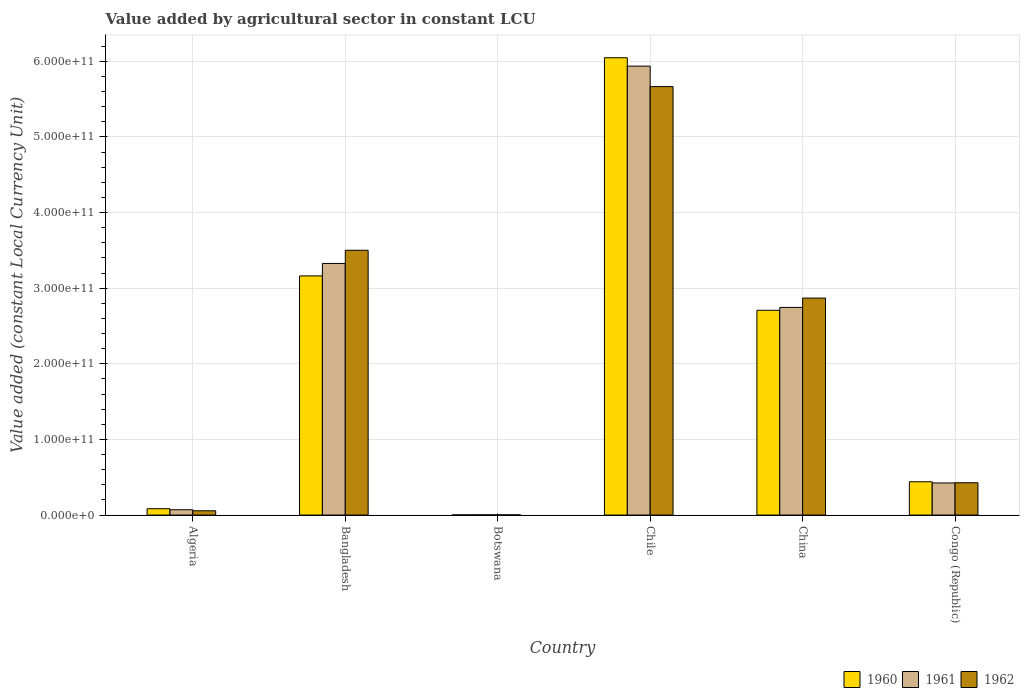How many different coloured bars are there?
Provide a short and direct response. 3. How many groups of bars are there?
Your answer should be compact. 6. How many bars are there on the 3rd tick from the right?
Keep it short and to the point. 3. In how many cases, is the number of bars for a given country not equal to the number of legend labels?
Offer a very short reply. 0. What is the value added by agricultural sector in 1961 in Chile?
Your answer should be compact. 5.94e+11. Across all countries, what is the maximum value added by agricultural sector in 1960?
Your answer should be very brief. 6.05e+11. Across all countries, what is the minimum value added by agricultural sector in 1960?
Your answer should be compact. 2.79e+08. In which country was the value added by agricultural sector in 1962 minimum?
Your answer should be very brief. Botswana. What is the total value added by agricultural sector in 1961 in the graph?
Keep it short and to the point. 1.25e+12. What is the difference between the value added by agricultural sector in 1960 in Bangladesh and that in Congo (Republic)?
Give a very brief answer. 2.72e+11. What is the difference between the value added by agricultural sector in 1962 in China and the value added by agricultural sector in 1961 in Congo (Republic)?
Keep it short and to the point. 2.44e+11. What is the average value added by agricultural sector in 1960 per country?
Offer a terse response. 2.07e+11. What is the difference between the value added by agricultural sector of/in 1961 and value added by agricultural sector of/in 1960 in Algeria?
Your answer should be very brief. -1.35e+09. What is the ratio of the value added by agricultural sector in 1961 in Bangladesh to that in Chile?
Provide a succinct answer. 0.56. What is the difference between the highest and the second highest value added by agricultural sector in 1960?
Give a very brief answer. -2.88e+11. What is the difference between the highest and the lowest value added by agricultural sector in 1961?
Keep it short and to the point. 5.93e+11. Is the sum of the value added by agricultural sector in 1962 in Algeria and Botswana greater than the maximum value added by agricultural sector in 1961 across all countries?
Your answer should be compact. No. What does the 2nd bar from the left in Chile represents?
Give a very brief answer. 1961. Is it the case that in every country, the sum of the value added by agricultural sector in 1961 and value added by agricultural sector in 1962 is greater than the value added by agricultural sector in 1960?
Your answer should be very brief. Yes. How many bars are there?
Your response must be concise. 18. How many countries are there in the graph?
Provide a short and direct response. 6. What is the difference between two consecutive major ticks on the Y-axis?
Offer a very short reply. 1.00e+11. Are the values on the major ticks of Y-axis written in scientific E-notation?
Give a very brief answer. Yes. Does the graph contain any zero values?
Your answer should be compact. No. Does the graph contain grids?
Provide a succinct answer. Yes. How are the legend labels stacked?
Keep it short and to the point. Horizontal. What is the title of the graph?
Give a very brief answer. Value added by agricultural sector in constant LCU. Does "1984" appear as one of the legend labels in the graph?
Your response must be concise. No. What is the label or title of the X-axis?
Your answer should be compact. Country. What is the label or title of the Y-axis?
Offer a terse response. Value added (constant Local Currency Unit). What is the Value added (constant Local Currency Unit) of 1960 in Algeria?
Your answer should be compact. 8.40e+09. What is the Value added (constant Local Currency Unit) in 1961 in Algeria?
Give a very brief answer. 7.05e+09. What is the Value added (constant Local Currency Unit) of 1962 in Algeria?
Keep it short and to the point. 5.66e+09. What is the Value added (constant Local Currency Unit) in 1960 in Bangladesh?
Offer a terse response. 3.16e+11. What is the Value added (constant Local Currency Unit) of 1961 in Bangladesh?
Provide a short and direct response. 3.33e+11. What is the Value added (constant Local Currency Unit) of 1962 in Bangladesh?
Provide a short and direct response. 3.50e+11. What is the Value added (constant Local Currency Unit) of 1960 in Botswana?
Ensure brevity in your answer.  2.79e+08. What is the Value added (constant Local Currency Unit) of 1961 in Botswana?
Offer a terse response. 2.86e+08. What is the Value added (constant Local Currency Unit) of 1962 in Botswana?
Provide a short and direct response. 2.96e+08. What is the Value added (constant Local Currency Unit) of 1960 in Chile?
Provide a succinct answer. 6.05e+11. What is the Value added (constant Local Currency Unit) in 1961 in Chile?
Offer a terse response. 5.94e+11. What is the Value added (constant Local Currency Unit) of 1962 in Chile?
Your answer should be very brief. 5.67e+11. What is the Value added (constant Local Currency Unit) in 1960 in China?
Provide a short and direct response. 2.71e+11. What is the Value added (constant Local Currency Unit) in 1961 in China?
Provide a short and direct response. 2.75e+11. What is the Value added (constant Local Currency Unit) in 1962 in China?
Your answer should be very brief. 2.87e+11. What is the Value added (constant Local Currency Unit) in 1960 in Congo (Republic)?
Make the answer very short. 4.41e+1. What is the Value added (constant Local Currency Unit) of 1961 in Congo (Republic)?
Your response must be concise. 4.25e+1. What is the Value added (constant Local Currency Unit) of 1962 in Congo (Republic)?
Ensure brevity in your answer.  4.27e+1. Across all countries, what is the maximum Value added (constant Local Currency Unit) of 1960?
Offer a very short reply. 6.05e+11. Across all countries, what is the maximum Value added (constant Local Currency Unit) in 1961?
Make the answer very short. 5.94e+11. Across all countries, what is the maximum Value added (constant Local Currency Unit) of 1962?
Provide a short and direct response. 5.67e+11. Across all countries, what is the minimum Value added (constant Local Currency Unit) of 1960?
Make the answer very short. 2.79e+08. Across all countries, what is the minimum Value added (constant Local Currency Unit) of 1961?
Your answer should be very brief. 2.86e+08. Across all countries, what is the minimum Value added (constant Local Currency Unit) of 1962?
Give a very brief answer. 2.96e+08. What is the total Value added (constant Local Currency Unit) in 1960 in the graph?
Make the answer very short. 1.24e+12. What is the total Value added (constant Local Currency Unit) in 1961 in the graph?
Make the answer very short. 1.25e+12. What is the total Value added (constant Local Currency Unit) of 1962 in the graph?
Make the answer very short. 1.25e+12. What is the difference between the Value added (constant Local Currency Unit) of 1960 in Algeria and that in Bangladesh?
Offer a very short reply. -3.08e+11. What is the difference between the Value added (constant Local Currency Unit) of 1961 in Algeria and that in Bangladesh?
Offer a very short reply. -3.26e+11. What is the difference between the Value added (constant Local Currency Unit) of 1962 in Algeria and that in Bangladesh?
Ensure brevity in your answer.  -3.44e+11. What is the difference between the Value added (constant Local Currency Unit) of 1960 in Algeria and that in Botswana?
Ensure brevity in your answer.  8.12e+09. What is the difference between the Value added (constant Local Currency Unit) of 1961 in Algeria and that in Botswana?
Give a very brief answer. 6.77e+09. What is the difference between the Value added (constant Local Currency Unit) in 1962 in Algeria and that in Botswana?
Offer a terse response. 5.36e+09. What is the difference between the Value added (constant Local Currency Unit) of 1960 in Algeria and that in Chile?
Provide a short and direct response. -5.96e+11. What is the difference between the Value added (constant Local Currency Unit) of 1961 in Algeria and that in Chile?
Provide a succinct answer. -5.87e+11. What is the difference between the Value added (constant Local Currency Unit) of 1962 in Algeria and that in Chile?
Keep it short and to the point. -5.61e+11. What is the difference between the Value added (constant Local Currency Unit) in 1960 in Algeria and that in China?
Keep it short and to the point. -2.62e+11. What is the difference between the Value added (constant Local Currency Unit) of 1961 in Algeria and that in China?
Ensure brevity in your answer.  -2.68e+11. What is the difference between the Value added (constant Local Currency Unit) of 1962 in Algeria and that in China?
Your response must be concise. -2.81e+11. What is the difference between the Value added (constant Local Currency Unit) of 1960 in Algeria and that in Congo (Republic)?
Your response must be concise. -3.57e+1. What is the difference between the Value added (constant Local Currency Unit) of 1961 in Algeria and that in Congo (Republic)?
Offer a very short reply. -3.54e+1. What is the difference between the Value added (constant Local Currency Unit) of 1962 in Algeria and that in Congo (Republic)?
Your response must be concise. -3.71e+1. What is the difference between the Value added (constant Local Currency Unit) in 1960 in Bangladesh and that in Botswana?
Your response must be concise. 3.16e+11. What is the difference between the Value added (constant Local Currency Unit) of 1961 in Bangladesh and that in Botswana?
Keep it short and to the point. 3.32e+11. What is the difference between the Value added (constant Local Currency Unit) in 1962 in Bangladesh and that in Botswana?
Offer a terse response. 3.50e+11. What is the difference between the Value added (constant Local Currency Unit) of 1960 in Bangladesh and that in Chile?
Make the answer very short. -2.88e+11. What is the difference between the Value added (constant Local Currency Unit) in 1961 in Bangladesh and that in Chile?
Ensure brevity in your answer.  -2.61e+11. What is the difference between the Value added (constant Local Currency Unit) of 1962 in Bangladesh and that in Chile?
Offer a terse response. -2.16e+11. What is the difference between the Value added (constant Local Currency Unit) in 1960 in Bangladesh and that in China?
Ensure brevity in your answer.  4.54e+1. What is the difference between the Value added (constant Local Currency Unit) of 1961 in Bangladesh and that in China?
Give a very brief answer. 5.81e+1. What is the difference between the Value added (constant Local Currency Unit) of 1962 in Bangladesh and that in China?
Make the answer very short. 6.32e+1. What is the difference between the Value added (constant Local Currency Unit) in 1960 in Bangladesh and that in Congo (Republic)?
Your answer should be very brief. 2.72e+11. What is the difference between the Value added (constant Local Currency Unit) in 1961 in Bangladesh and that in Congo (Republic)?
Keep it short and to the point. 2.90e+11. What is the difference between the Value added (constant Local Currency Unit) of 1962 in Bangladesh and that in Congo (Republic)?
Your answer should be very brief. 3.07e+11. What is the difference between the Value added (constant Local Currency Unit) in 1960 in Botswana and that in Chile?
Offer a terse response. -6.04e+11. What is the difference between the Value added (constant Local Currency Unit) in 1961 in Botswana and that in Chile?
Make the answer very short. -5.93e+11. What is the difference between the Value added (constant Local Currency Unit) in 1962 in Botswana and that in Chile?
Provide a succinct answer. -5.66e+11. What is the difference between the Value added (constant Local Currency Unit) of 1960 in Botswana and that in China?
Make the answer very short. -2.70e+11. What is the difference between the Value added (constant Local Currency Unit) in 1961 in Botswana and that in China?
Provide a succinct answer. -2.74e+11. What is the difference between the Value added (constant Local Currency Unit) in 1962 in Botswana and that in China?
Provide a succinct answer. -2.87e+11. What is the difference between the Value added (constant Local Currency Unit) in 1960 in Botswana and that in Congo (Republic)?
Make the answer very short. -4.38e+1. What is the difference between the Value added (constant Local Currency Unit) in 1961 in Botswana and that in Congo (Republic)?
Make the answer very short. -4.22e+1. What is the difference between the Value added (constant Local Currency Unit) of 1962 in Botswana and that in Congo (Republic)?
Your answer should be compact. -4.24e+1. What is the difference between the Value added (constant Local Currency Unit) of 1960 in Chile and that in China?
Your answer should be very brief. 3.34e+11. What is the difference between the Value added (constant Local Currency Unit) in 1961 in Chile and that in China?
Make the answer very short. 3.19e+11. What is the difference between the Value added (constant Local Currency Unit) of 1962 in Chile and that in China?
Make the answer very short. 2.80e+11. What is the difference between the Value added (constant Local Currency Unit) in 1960 in Chile and that in Congo (Republic)?
Provide a succinct answer. 5.61e+11. What is the difference between the Value added (constant Local Currency Unit) in 1961 in Chile and that in Congo (Republic)?
Provide a succinct answer. 5.51e+11. What is the difference between the Value added (constant Local Currency Unit) in 1962 in Chile and that in Congo (Republic)?
Offer a terse response. 5.24e+11. What is the difference between the Value added (constant Local Currency Unit) of 1960 in China and that in Congo (Republic)?
Make the answer very short. 2.27e+11. What is the difference between the Value added (constant Local Currency Unit) in 1961 in China and that in Congo (Republic)?
Ensure brevity in your answer.  2.32e+11. What is the difference between the Value added (constant Local Currency Unit) of 1962 in China and that in Congo (Republic)?
Ensure brevity in your answer.  2.44e+11. What is the difference between the Value added (constant Local Currency Unit) of 1960 in Algeria and the Value added (constant Local Currency Unit) of 1961 in Bangladesh?
Your response must be concise. -3.24e+11. What is the difference between the Value added (constant Local Currency Unit) in 1960 in Algeria and the Value added (constant Local Currency Unit) in 1962 in Bangladesh?
Make the answer very short. -3.42e+11. What is the difference between the Value added (constant Local Currency Unit) in 1961 in Algeria and the Value added (constant Local Currency Unit) in 1962 in Bangladesh?
Your answer should be very brief. -3.43e+11. What is the difference between the Value added (constant Local Currency Unit) of 1960 in Algeria and the Value added (constant Local Currency Unit) of 1961 in Botswana?
Ensure brevity in your answer.  8.11e+09. What is the difference between the Value added (constant Local Currency Unit) in 1960 in Algeria and the Value added (constant Local Currency Unit) in 1962 in Botswana?
Your answer should be compact. 8.10e+09. What is the difference between the Value added (constant Local Currency Unit) in 1961 in Algeria and the Value added (constant Local Currency Unit) in 1962 in Botswana?
Your answer should be compact. 6.76e+09. What is the difference between the Value added (constant Local Currency Unit) of 1960 in Algeria and the Value added (constant Local Currency Unit) of 1961 in Chile?
Provide a succinct answer. -5.85e+11. What is the difference between the Value added (constant Local Currency Unit) of 1960 in Algeria and the Value added (constant Local Currency Unit) of 1962 in Chile?
Your answer should be very brief. -5.58e+11. What is the difference between the Value added (constant Local Currency Unit) in 1961 in Algeria and the Value added (constant Local Currency Unit) in 1962 in Chile?
Give a very brief answer. -5.59e+11. What is the difference between the Value added (constant Local Currency Unit) of 1960 in Algeria and the Value added (constant Local Currency Unit) of 1961 in China?
Provide a succinct answer. -2.66e+11. What is the difference between the Value added (constant Local Currency Unit) of 1960 in Algeria and the Value added (constant Local Currency Unit) of 1962 in China?
Give a very brief answer. -2.79e+11. What is the difference between the Value added (constant Local Currency Unit) of 1961 in Algeria and the Value added (constant Local Currency Unit) of 1962 in China?
Your answer should be very brief. -2.80e+11. What is the difference between the Value added (constant Local Currency Unit) of 1960 in Algeria and the Value added (constant Local Currency Unit) of 1961 in Congo (Republic)?
Your response must be concise. -3.41e+1. What is the difference between the Value added (constant Local Currency Unit) of 1960 in Algeria and the Value added (constant Local Currency Unit) of 1962 in Congo (Republic)?
Ensure brevity in your answer.  -3.43e+1. What is the difference between the Value added (constant Local Currency Unit) of 1961 in Algeria and the Value added (constant Local Currency Unit) of 1962 in Congo (Republic)?
Your answer should be very brief. -3.57e+1. What is the difference between the Value added (constant Local Currency Unit) of 1960 in Bangladesh and the Value added (constant Local Currency Unit) of 1961 in Botswana?
Offer a terse response. 3.16e+11. What is the difference between the Value added (constant Local Currency Unit) of 1960 in Bangladesh and the Value added (constant Local Currency Unit) of 1962 in Botswana?
Ensure brevity in your answer.  3.16e+11. What is the difference between the Value added (constant Local Currency Unit) of 1961 in Bangladesh and the Value added (constant Local Currency Unit) of 1962 in Botswana?
Offer a very short reply. 3.32e+11. What is the difference between the Value added (constant Local Currency Unit) of 1960 in Bangladesh and the Value added (constant Local Currency Unit) of 1961 in Chile?
Your answer should be compact. -2.77e+11. What is the difference between the Value added (constant Local Currency Unit) in 1960 in Bangladesh and the Value added (constant Local Currency Unit) in 1962 in Chile?
Your answer should be compact. -2.50e+11. What is the difference between the Value added (constant Local Currency Unit) in 1961 in Bangladesh and the Value added (constant Local Currency Unit) in 1962 in Chile?
Give a very brief answer. -2.34e+11. What is the difference between the Value added (constant Local Currency Unit) of 1960 in Bangladesh and the Value added (constant Local Currency Unit) of 1961 in China?
Your response must be concise. 4.17e+1. What is the difference between the Value added (constant Local Currency Unit) of 1960 in Bangladesh and the Value added (constant Local Currency Unit) of 1962 in China?
Your answer should be very brief. 2.93e+1. What is the difference between the Value added (constant Local Currency Unit) of 1961 in Bangladesh and the Value added (constant Local Currency Unit) of 1962 in China?
Offer a terse response. 4.58e+1. What is the difference between the Value added (constant Local Currency Unit) in 1960 in Bangladesh and the Value added (constant Local Currency Unit) in 1961 in Congo (Republic)?
Offer a terse response. 2.74e+11. What is the difference between the Value added (constant Local Currency Unit) in 1960 in Bangladesh and the Value added (constant Local Currency Unit) in 1962 in Congo (Republic)?
Your answer should be compact. 2.73e+11. What is the difference between the Value added (constant Local Currency Unit) of 1961 in Bangladesh and the Value added (constant Local Currency Unit) of 1962 in Congo (Republic)?
Provide a succinct answer. 2.90e+11. What is the difference between the Value added (constant Local Currency Unit) in 1960 in Botswana and the Value added (constant Local Currency Unit) in 1961 in Chile?
Provide a succinct answer. -5.93e+11. What is the difference between the Value added (constant Local Currency Unit) in 1960 in Botswana and the Value added (constant Local Currency Unit) in 1962 in Chile?
Provide a short and direct response. -5.66e+11. What is the difference between the Value added (constant Local Currency Unit) of 1961 in Botswana and the Value added (constant Local Currency Unit) of 1962 in Chile?
Offer a very short reply. -5.66e+11. What is the difference between the Value added (constant Local Currency Unit) of 1960 in Botswana and the Value added (constant Local Currency Unit) of 1961 in China?
Provide a succinct answer. -2.74e+11. What is the difference between the Value added (constant Local Currency Unit) of 1960 in Botswana and the Value added (constant Local Currency Unit) of 1962 in China?
Give a very brief answer. -2.87e+11. What is the difference between the Value added (constant Local Currency Unit) of 1961 in Botswana and the Value added (constant Local Currency Unit) of 1962 in China?
Give a very brief answer. -2.87e+11. What is the difference between the Value added (constant Local Currency Unit) in 1960 in Botswana and the Value added (constant Local Currency Unit) in 1961 in Congo (Republic)?
Your answer should be very brief. -4.22e+1. What is the difference between the Value added (constant Local Currency Unit) of 1960 in Botswana and the Value added (constant Local Currency Unit) of 1962 in Congo (Republic)?
Keep it short and to the point. -4.25e+1. What is the difference between the Value added (constant Local Currency Unit) of 1961 in Botswana and the Value added (constant Local Currency Unit) of 1962 in Congo (Republic)?
Your answer should be compact. -4.25e+1. What is the difference between the Value added (constant Local Currency Unit) in 1960 in Chile and the Value added (constant Local Currency Unit) in 1961 in China?
Provide a short and direct response. 3.30e+11. What is the difference between the Value added (constant Local Currency Unit) in 1960 in Chile and the Value added (constant Local Currency Unit) in 1962 in China?
Ensure brevity in your answer.  3.18e+11. What is the difference between the Value added (constant Local Currency Unit) of 1961 in Chile and the Value added (constant Local Currency Unit) of 1962 in China?
Offer a terse response. 3.07e+11. What is the difference between the Value added (constant Local Currency Unit) in 1960 in Chile and the Value added (constant Local Currency Unit) in 1961 in Congo (Republic)?
Provide a short and direct response. 5.62e+11. What is the difference between the Value added (constant Local Currency Unit) of 1960 in Chile and the Value added (constant Local Currency Unit) of 1962 in Congo (Republic)?
Offer a terse response. 5.62e+11. What is the difference between the Value added (constant Local Currency Unit) in 1961 in Chile and the Value added (constant Local Currency Unit) in 1962 in Congo (Republic)?
Provide a succinct answer. 5.51e+11. What is the difference between the Value added (constant Local Currency Unit) in 1960 in China and the Value added (constant Local Currency Unit) in 1961 in Congo (Republic)?
Give a very brief answer. 2.28e+11. What is the difference between the Value added (constant Local Currency Unit) of 1960 in China and the Value added (constant Local Currency Unit) of 1962 in Congo (Republic)?
Offer a terse response. 2.28e+11. What is the difference between the Value added (constant Local Currency Unit) in 1961 in China and the Value added (constant Local Currency Unit) in 1962 in Congo (Republic)?
Your answer should be compact. 2.32e+11. What is the average Value added (constant Local Currency Unit) of 1960 per country?
Offer a terse response. 2.07e+11. What is the average Value added (constant Local Currency Unit) in 1961 per country?
Offer a terse response. 2.08e+11. What is the average Value added (constant Local Currency Unit) of 1962 per country?
Offer a terse response. 2.09e+11. What is the difference between the Value added (constant Local Currency Unit) in 1960 and Value added (constant Local Currency Unit) in 1961 in Algeria?
Offer a very short reply. 1.35e+09. What is the difference between the Value added (constant Local Currency Unit) of 1960 and Value added (constant Local Currency Unit) of 1962 in Algeria?
Ensure brevity in your answer.  2.74e+09. What is the difference between the Value added (constant Local Currency Unit) of 1961 and Value added (constant Local Currency Unit) of 1962 in Algeria?
Provide a succinct answer. 1.40e+09. What is the difference between the Value added (constant Local Currency Unit) in 1960 and Value added (constant Local Currency Unit) in 1961 in Bangladesh?
Your answer should be very brief. -1.65e+1. What is the difference between the Value added (constant Local Currency Unit) of 1960 and Value added (constant Local Currency Unit) of 1962 in Bangladesh?
Your answer should be compact. -3.39e+1. What is the difference between the Value added (constant Local Currency Unit) in 1961 and Value added (constant Local Currency Unit) in 1962 in Bangladesh?
Offer a terse response. -1.75e+1. What is the difference between the Value added (constant Local Currency Unit) of 1960 and Value added (constant Local Currency Unit) of 1961 in Botswana?
Make the answer very short. -6.88e+06. What is the difference between the Value added (constant Local Currency Unit) of 1960 and Value added (constant Local Currency Unit) of 1962 in Botswana?
Give a very brief answer. -1.72e+07. What is the difference between the Value added (constant Local Currency Unit) of 1961 and Value added (constant Local Currency Unit) of 1962 in Botswana?
Provide a succinct answer. -1.03e+07. What is the difference between the Value added (constant Local Currency Unit) of 1960 and Value added (constant Local Currency Unit) of 1961 in Chile?
Offer a very short reply. 1.11e+1. What is the difference between the Value added (constant Local Currency Unit) in 1960 and Value added (constant Local Currency Unit) in 1962 in Chile?
Offer a very short reply. 3.82e+1. What is the difference between the Value added (constant Local Currency Unit) of 1961 and Value added (constant Local Currency Unit) of 1962 in Chile?
Make the answer very short. 2.70e+1. What is the difference between the Value added (constant Local Currency Unit) of 1960 and Value added (constant Local Currency Unit) of 1961 in China?
Your response must be concise. -3.79e+09. What is the difference between the Value added (constant Local Currency Unit) in 1960 and Value added (constant Local Currency Unit) in 1962 in China?
Provide a short and direct response. -1.61e+1. What is the difference between the Value added (constant Local Currency Unit) in 1961 and Value added (constant Local Currency Unit) in 1962 in China?
Give a very brief answer. -1.24e+1. What is the difference between the Value added (constant Local Currency Unit) in 1960 and Value added (constant Local Currency Unit) in 1961 in Congo (Republic)?
Keep it short and to the point. 1.57e+09. What is the difference between the Value added (constant Local Currency Unit) in 1960 and Value added (constant Local Currency Unit) in 1962 in Congo (Republic)?
Provide a succinct answer. 1.32e+09. What is the difference between the Value added (constant Local Currency Unit) in 1961 and Value added (constant Local Currency Unit) in 1962 in Congo (Republic)?
Ensure brevity in your answer.  -2.56e+08. What is the ratio of the Value added (constant Local Currency Unit) in 1960 in Algeria to that in Bangladesh?
Offer a terse response. 0.03. What is the ratio of the Value added (constant Local Currency Unit) in 1961 in Algeria to that in Bangladesh?
Offer a terse response. 0.02. What is the ratio of the Value added (constant Local Currency Unit) in 1962 in Algeria to that in Bangladesh?
Your answer should be compact. 0.02. What is the ratio of the Value added (constant Local Currency Unit) of 1960 in Algeria to that in Botswana?
Your answer should be compact. 30.08. What is the ratio of the Value added (constant Local Currency Unit) of 1961 in Algeria to that in Botswana?
Ensure brevity in your answer.  24.65. What is the ratio of the Value added (constant Local Currency Unit) in 1962 in Algeria to that in Botswana?
Your answer should be very brief. 19.09. What is the ratio of the Value added (constant Local Currency Unit) in 1960 in Algeria to that in Chile?
Provide a succinct answer. 0.01. What is the ratio of the Value added (constant Local Currency Unit) in 1961 in Algeria to that in Chile?
Offer a terse response. 0.01. What is the ratio of the Value added (constant Local Currency Unit) in 1962 in Algeria to that in Chile?
Your answer should be compact. 0.01. What is the ratio of the Value added (constant Local Currency Unit) in 1960 in Algeria to that in China?
Your answer should be compact. 0.03. What is the ratio of the Value added (constant Local Currency Unit) of 1961 in Algeria to that in China?
Your response must be concise. 0.03. What is the ratio of the Value added (constant Local Currency Unit) of 1962 in Algeria to that in China?
Your answer should be very brief. 0.02. What is the ratio of the Value added (constant Local Currency Unit) of 1960 in Algeria to that in Congo (Republic)?
Your answer should be very brief. 0.19. What is the ratio of the Value added (constant Local Currency Unit) in 1961 in Algeria to that in Congo (Republic)?
Ensure brevity in your answer.  0.17. What is the ratio of the Value added (constant Local Currency Unit) in 1962 in Algeria to that in Congo (Republic)?
Keep it short and to the point. 0.13. What is the ratio of the Value added (constant Local Currency Unit) of 1960 in Bangladesh to that in Botswana?
Provide a short and direct response. 1132.8. What is the ratio of the Value added (constant Local Currency Unit) of 1961 in Bangladesh to that in Botswana?
Offer a very short reply. 1163.15. What is the ratio of the Value added (constant Local Currency Unit) of 1962 in Bangladesh to that in Botswana?
Give a very brief answer. 1181.56. What is the ratio of the Value added (constant Local Currency Unit) in 1960 in Bangladesh to that in Chile?
Offer a terse response. 0.52. What is the ratio of the Value added (constant Local Currency Unit) in 1961 in Bangladesh to that in Chile?
Keep it short and to the point. 0.56. What is the ratio of the Value added (constant Local Currency Unit) in 1962 in Bangladesh to that in Chile?
Provide a succinct answer. 0.62. What is the ratio of the Value added (constant Local Currency Unit) in 1960 in Bangladesh to that in China?
Provide a succinct answer. 1.17. What is the ratio of the Value added (constant Local Currency Unit) in 1961 in Bangladesh to that in China?
Your response must be concise. 1.21. What is the ratio of the Value added (constant Local Currency Unit) of 1962 in Bangladesh to that in China?
Offer a terse response. 1.22. What is the ratio of the Value added (constant Local Currency Unit) of 1960 in Bangladesh to that in Congo (Republic)?
Your response must be concise. 7.18. What is the ratio of the Value added (constant Local Currency Unit) in 1961 in Bangladesh to that in Congo (Republic)?
Your answer should be very brief. 7.83. What is the ratio of the Value added (constant Local Currency Unit) in 1962 in Bangladesh to that in Congo (Republic)?
Your answer should be very brief. 8.19. What is the ratio of the Value added (constant Local Currency Unit) of 1960 in Botswana to that in Chile?
Your answer should be very brief. 0. What is the ratio of the Value added (constant Local Currency Unit) in 1962 in Botswana to that in Chile?
Provide a short and direct response. 0. What is the ratio of the Value added (constant Local Currency Unit) of 1961 in Botswana to that in China?
Make the answer very short. 0. What is the ratio of the Value added (constant Local Currency Unit) in 1962 in Botswana to that in China?
Make the answer very short. 0. What is the ratio of the Value added (constant Local Currency Unit) in 1960 in Botswana to that in Congo (Republic)?
Your answer should be compact. 0.01. What is the ratio of the Value added (constant Local Currency Unit) in 1961 in Botswana to that in Congo (Republic)?
Offer a terse response. 0.01. What is the ratio of the Value added (constant Local Currency Unit) of 1962 in Botswana to that in Congo (Republic)?
Provide a succinct answer. 0.01. What is the ratio of the Value added (constant Local Currency Unit) of 1960 in Chile to that in China?
Keep it short and to the point. 2.23. What is the ratio of the Value added (constant Local Currency Unit) in 1961 in Chile to that in China?
Your answer should be compact. 2.16. What is the ratio of the Value added (constant Local Currency Unit) of 1962 in Chile to that in China?
Offer a very short reply. 1.97. What is the ratio of the Value added (constant Local Currency Unit) in 1960 in Chile to that in Congo (Republic)?
Offer a terse response. 13.73. What is the ratio of the Value added (constant Local Currency Unit) in 1961 in Chile to that in Congo (Republic)?
Offer a very short reply. 13.97. What is the ratio of the Value added (constant Local Currency Unit) of 1962 in Chile to that in Congo (Republic)?
Offer a terse response. 13.26. What is the ratio of the Value added (constant Local Currency Unit) of 1960 in China to that in Congo (Republic)?
Give a very brief answer. 6.15. What is the ratio of the Value added (constant Local Currency Unit) of 1961 in China to that in Congo (Republic)?
Provide a succinct answer. 6.46. What is the ratio of the Value added (constant Local Currency Unit) of 1962 in China to that in Congo (Republic)?
Offer a very short reply. 6.71. What is the difference between the highest and the second highest Value added (constant Local Currency Unit) in 1960?
Your response must be concise. 2.88e+11. What is the difference between the highest and the second highest Value added (constant Local Currency Unit) of 1961?
Your answer should be compact. 2.61e+11. What is the difference between the highest and the second highest Value added (constant Local Currency Unit) of 1962?
Offer a very short reply. 2.16e+11. What is the difference between the highest and the lowest Value added (constant Local Currency Unit) of 1960?
Your answer should be very brief. 6.04e+11. What is the difference between the highest and the lowest Value added (constant Local Currency Unit) in 1961?
Your response must be concise. 5.93e+11. What is the difference between the highest and the lowest Value added (constant Local Currency Unit) of 1962?
Offer a very short reply. 5.66e+11. 